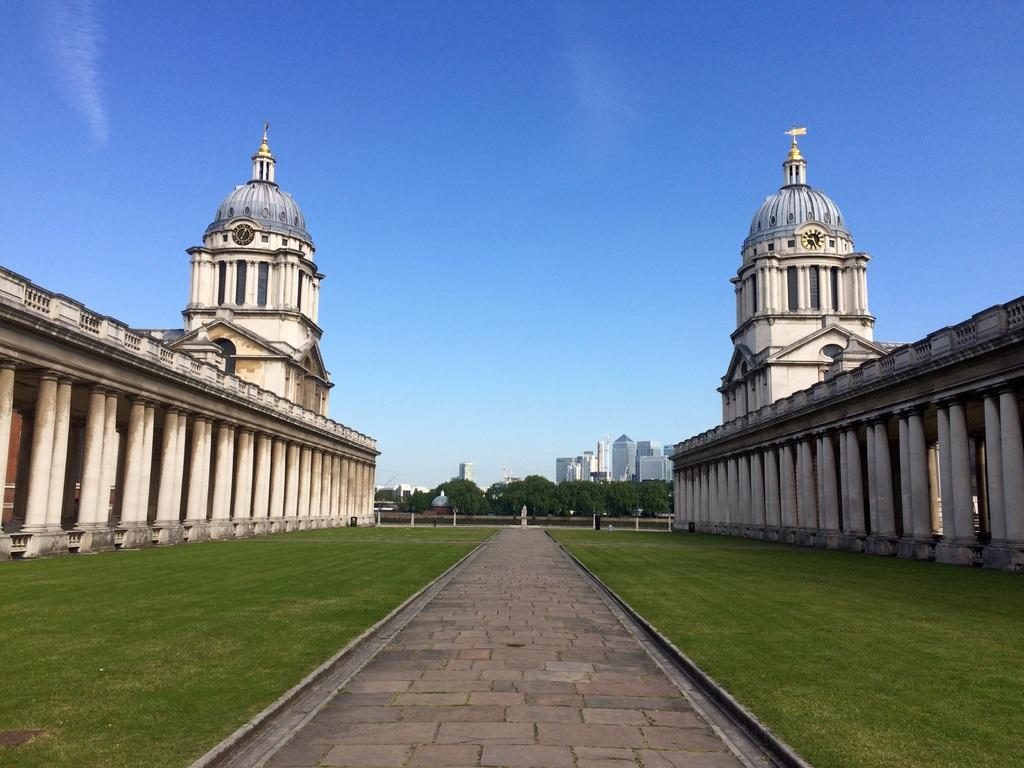What type of structures are present in the image? There are buildings in the image. What other natural elements can be seen in the image? There are trees and grass in the image. What feature is present on the buildings? There are clocks on the buildings. What is visible at the top of the image? The sky is visible at the top of the image. What is present at the bottom of the image? There is a pavement at the bottom of the image. Where is the cave located in the image? There is no cave present in the image. What color is the elbow of the person in the image? There is no person present in the image, so there is no elbow to describe. 